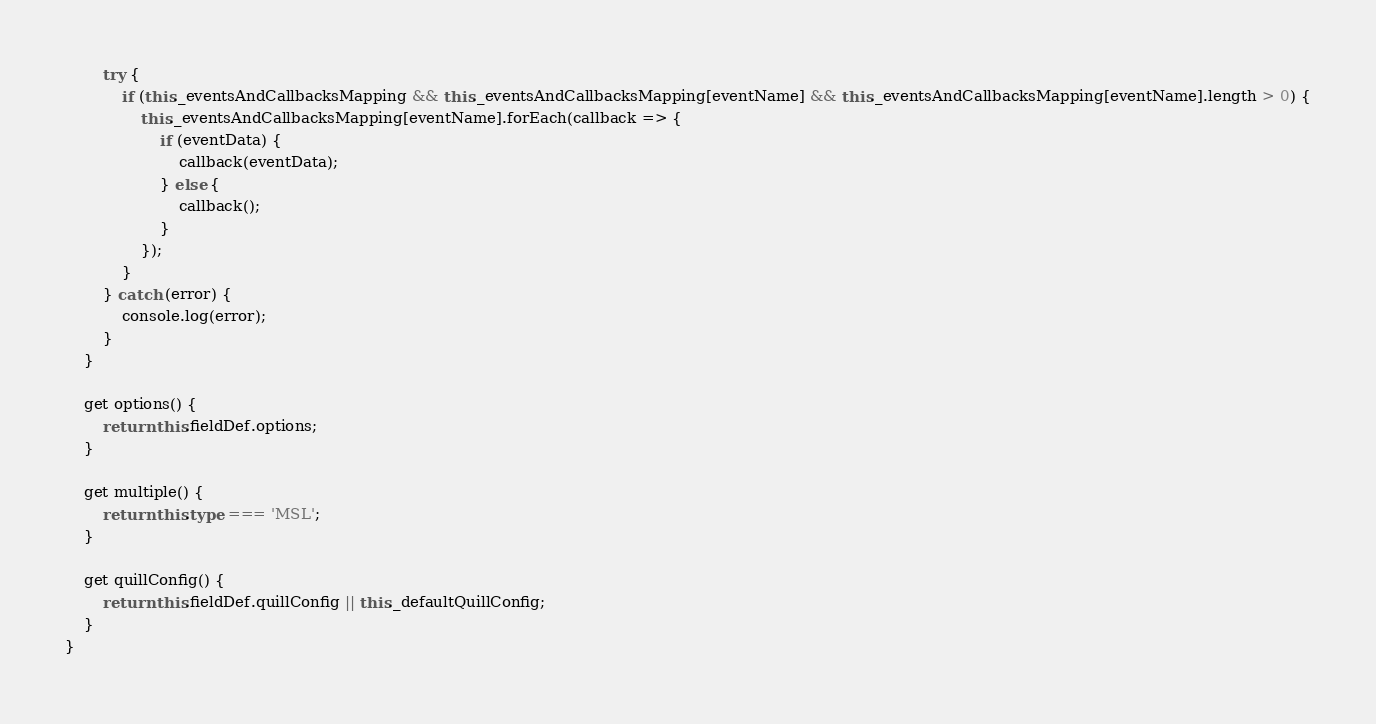Convert code to text. <code><loc_0><loc_0><loc_500><loc_500><_TypeScript_>		try {
			if (this._eventsAndCallbacksMapping && this._eventsAndCallbacksMapping[eventName] && this._eventsAndCallbacksMapping[eventName].length > 0) {
				this._eventsAndCallbacksMapping[eventName].forEach(callback => {
					if (eventData) {
						callback(eventData);
					} else {
						callback();
					}
				});
			}
		} catch (error) {
			console.log(error);
		}
	}

	get options() {
		return this.fieldDef.options;
	}

	get multiple() {
		return this.type === 'MSL';
	}

	get quillConfig() {
		return this.fieldDef.quillConfig || this._defaultQuillConfig;
	}
}
</code> 